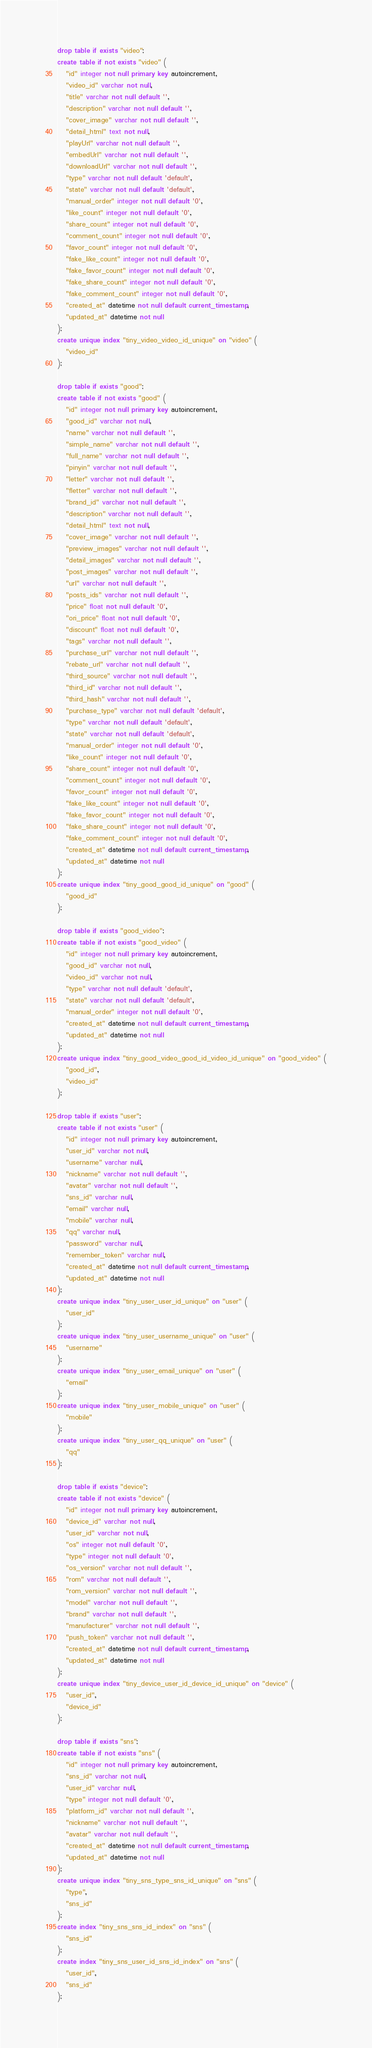<code> <loc_0><loc_0><loc_500><loc_500><_SQL_>drop table if exists "video";
create table if not exists "video" (
   "id" integer not null primary key autoincrement,
   "video_id" varchar not null,
   "title" varchar not null default '',
   "description" varchar not null default '',
   "cover_image" varchar not null default '',
   "detail_html" text not null,
   "playUrl" varchar not null default '',
   "embedUrl" varchar not null default '',
   "downloadUrl" varchar not null default '',
   "type" varchar not null default 'default',
   "state" varchar not null default 'default',
   "manual_order" integer not null default '0',
   "like_count" integer not null default '0',
   "share_count" integer not null default '0',
   "comment_count" integer not null default '0',
   "favor_count" integer not null default '0',
   "fake_like_count" integer not null default '0',
   "fake_favor_count" integer not null default '0',
   "fake_share_count" integer not null default '0',
   "fake_comment_count" integer not null default '0',
   "created_at" datetime not null default current_timestamp,
   "updated_at" datetime not null
);
create unique index "tiny_video_video_id_unique" on "video" (
   "video_id"
);

drop table if exists "good";
create table if not exists "good" (
   "id" integer not null primary key autoincrement,
   "good_id" varchar not null,
   "name" varchar not null default '',
   "simple_name" varchar not null default '',
   "full_name" varchar not null default '',
   "pinyin" varchar not null default '',
   "letter" varchar not null default '',
   "fletter" varchar not null default '',
   "brand_id" varchar not null default '',
   "description" varchar not null default '',
   "detail_html" text not null,
   "cover_image" varchar not null default '',
   "preview_images" varchar not null default '',
   "detail_images" varchar not null default '',
   "post_images" varchar not null default '',
   "url" varchar not null default '',
   "posts_ids" varchar not null default '',
   "price" float not null default '0',
   "ori_price" float not null default '0',
   "discount" float not null default '0',
   "tags" varchar not null default '',
   "purchase_url" varchar not null default '',
   "rebate_url" varchar not null default '',
   "third_source" varchar not null default '',
   "third_id" varchar not null default '',
   "third_hash" varchar not null default '',
   "purchase_type" varchar not null default 'default',
   "type" varchar not null default 'default',
   "state" varchar not null default 'default',
   "manual_order" integer not null default '0',
   "like_count" integer not null default '0',
   "share_count" integer not null default '0',
   "comment_count" integer not null default '0',
   "favor_count" integer not null default '0',
   "fake_like_count" integer not null default '0',
   "fake_favor_count" integer not null default '0',
   "fake_share_count" integer not null default '0',
   "fake_comment_count" integer not null default '0',
   "created_at" datetime not null default current_timestamp,
   "updated_at" datetime not null
);
create unique index "tiny_good_good_id_unique" on "good" (
   "good_id"
);

drop table if exists "good_video";
create table if not exists "good_video" (
   "id" integer not null primary key autoincrement,
   "good_id" varchar not null,
   "video_id" varchar not null,
   "type" varchar not null default 'default',
   "state" varchar not null default 'default',
   "manual_order" integer not null default '0',
   "created_at" datetime not null default current_timestamp,
   "updated_at" datetime not null
);
create unique index "tiny_good_video_good_id_video_id_unique" on "good_video" (
   "good_id",
   "video_id"
);

drop table if exists "user";
create table if not exists "user" (
   "id" integer not null primary key autoincrement,
   "user_id" varchar not null,
   "username" varchar null,
   "nickname" varchar not null default '',
   "avatar" varchar not null default '',
   "sns_id" varchar null,
   "email" varchar null,
   "mobile" varchar null,
   "qq" varchar null,
   "password" varchar null,
   "remember_token" varchar null,
   "created_at" datetime not null default current_timestamp,
   "updated_at" datetime not null
);
create unique index "tiny_user_user_id_unique" on "user" (
   "user_id"
);
create unique index "tiny_user_username_unique" on "user" (
   "username"
);
create unique index "tiny_user_email_unique" on "user" (
   "email"
);
create unique index "tiny_user_mobile_unique" on "user" (
   "mobile"
);
create unique index "tiny_user_qq_unique" on "user" (
   "qq"
);

drop table if exists "device";
create table if not exists "device" (
   "id" integer not null primary key autoincrement,
   "device_id" varchar not null,
   "user_id" varchar not null,
   "os" integer not null default '0',
   "type" integer not null default '0',
   "os_version" varchar not null default '',
   "rom" varchar not null default '',
   "rom_version" varchar not null default '',
   "model" varchar not null default '',
   "brand" varchar not null default '',
   "manufacturer" varchar not null default '',
   "push_token" varchar not null default '',
   "created_at" datetime not null default current_timestamp,
   "updated_at" datetime not null
);
create unique index "tiny_device_user_id_device_id_unique" on "device" (
   "user_id",
   "device_id"
);

drop table if exists "sns";
create table if not exists "sns" (
   "id" integer not null primary key autoincrement,
   "sns_id" varchar not null,
   "user_id" varchar null,
   "type" integer not null default '0',
   "platform_id" varchar not null default '',
   "nickname" varchar not null default '',
   "avatar" varchar not null default '',
   "created_at" datetime not null default current_timestamp,
   "updated_at" datetime not null
);
create unique index "tiny_sns_type_sns_id_unique" on "sns" (
   "type",
   "sns_id"
);
create index "tiny_sns_sns_id_index" on "sns" (
   "sns_id"
);
create index "tiny_sns_user_id_sns_id_index" on "sns" (
   "user_id",
   "sns_id"
);
</code> 